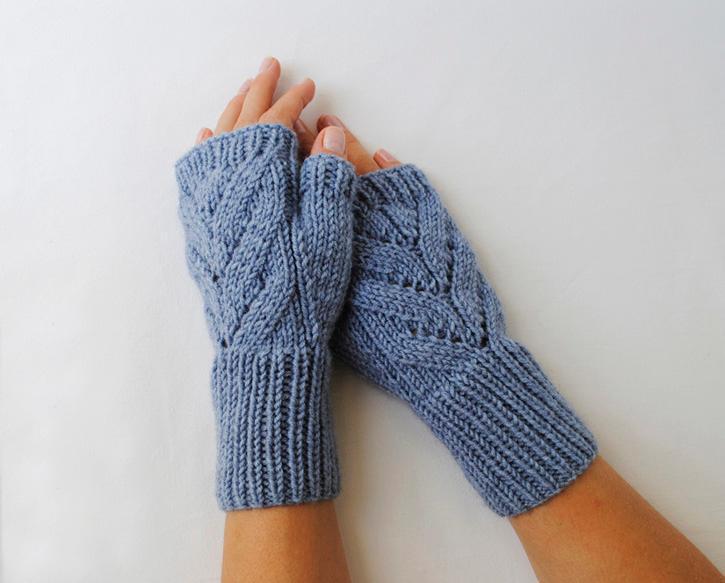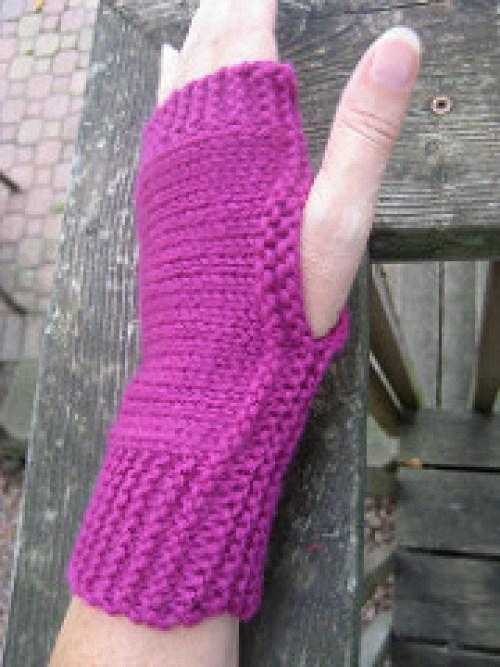The first image is the image on the left, the second image is the image on the right. Assess this claim about the two images: "In one image there is exactly one human hand modeling a fingerless glove.". Correct or not? Answer yes or no. Yes. The first image is the image on the left, the second image is the image on the right. Given the left and right images, does the statement "Both images feature a soild-colored fingerless yarn mitten modeled by a human hand." hold true? Answer yes or no. Yes. 